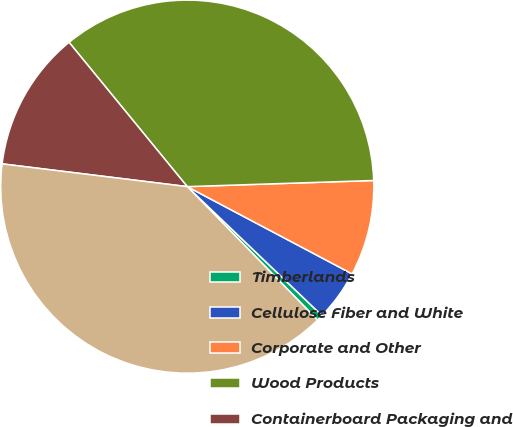Convert chart. <chart><loc_0><loc_0><loc_500><loc_500><pie_chart><fcel>Timberlands<fcel>Cellulose Fiber and White<fcel>Corporate and Other<fcel>Wood Products<fcel>Containerboard Packaging and<fcel>Real Estate and Related Assets<nl><fcel>0.54%<fcel>4.4%<fcel>8.27%<fcel>35.4%<fcel>12.13%<fcel>39.26%<nl></chart> 